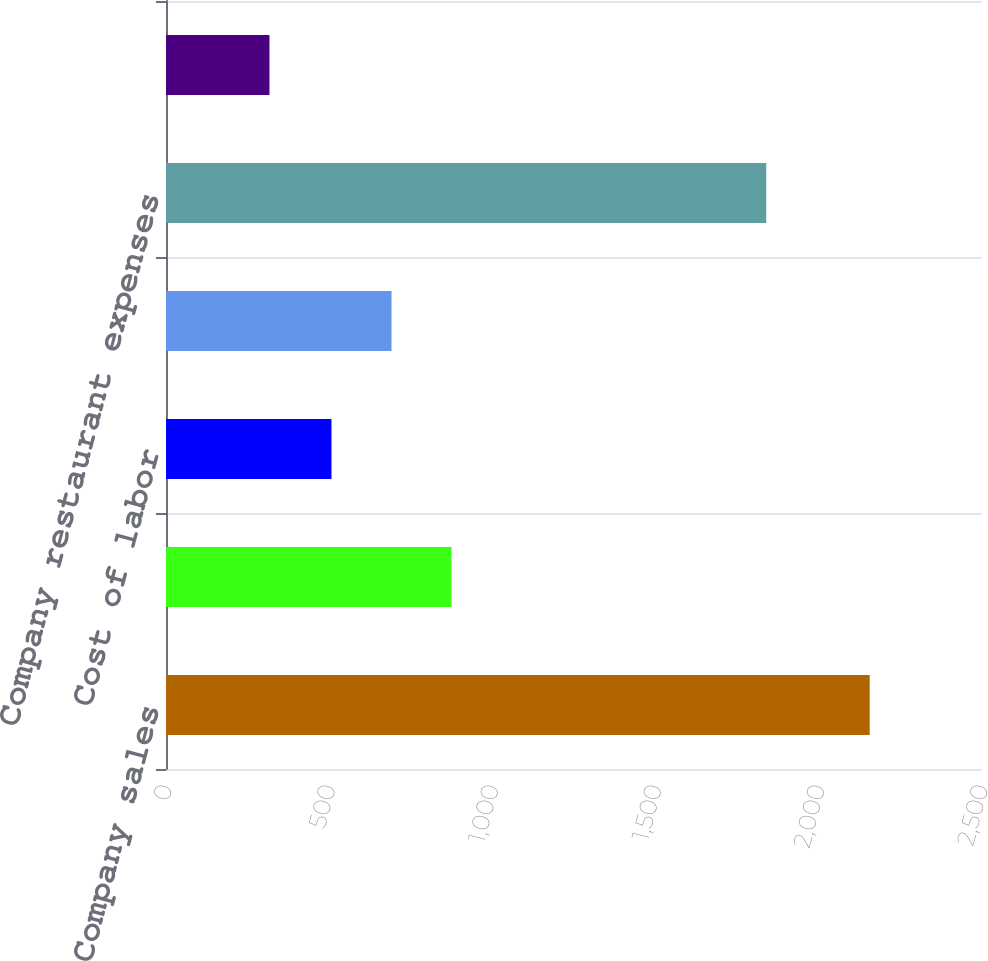Convert chart to OTSL. <chart><loc_0><loc_0><loc_500><loc_500><bar_chart><fcel>Company sales<fcel>Cost of sales<fcel>Cost of labor<fcel>Occupancy and other<fcel>Company restaurant expenses<fcel>Restaurant profit<nl><fcel>2156<fcel>874.8<fcel>507<fcel>690.9<fcel>1839<fcel>317<nl></chart> 